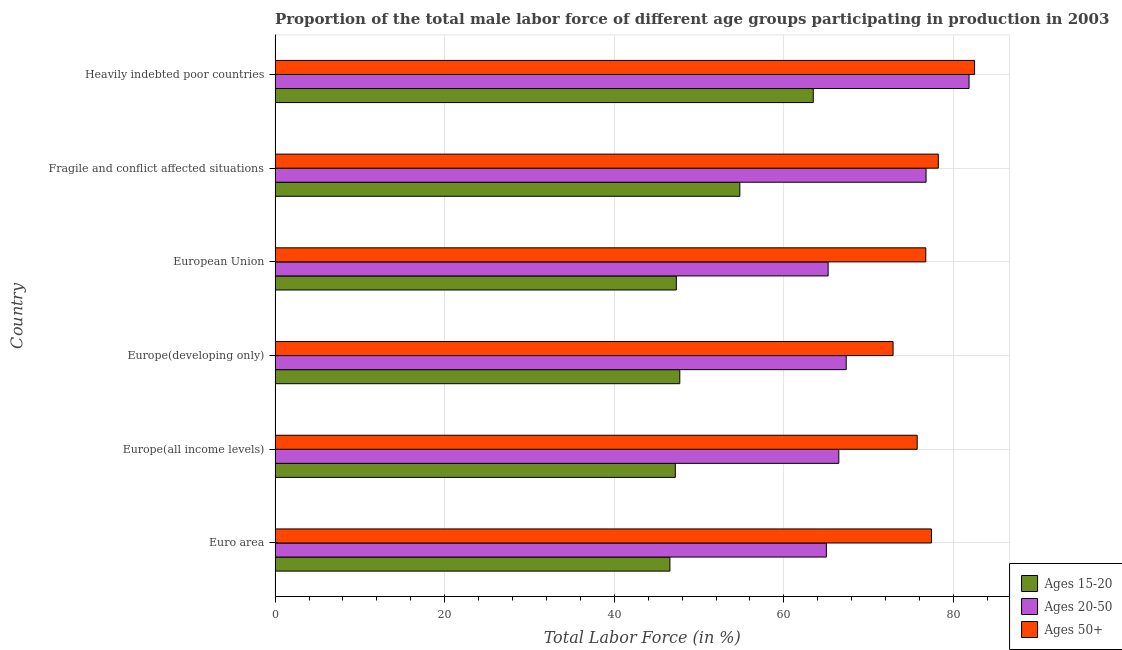How many different coloured bars are there?
Provide a short and direct response. 3. How many bars are there on the 3rd tick from the top?
Your answer should be compact. 3. How many bars are there on the 4th tick from the bottom?
Ensure brevity in your answer.  3. What is the label of the 6th group of bars from the top?
Offer a terse response. Euro area. What is the percentage of male labor force within the age group 20-50 in European Union?
Keep it short and to the point. 65.22. Across all countries, what is the maximum percentage of male labor force above age 50?
Offer a terse response. 82.49. Across all countries, what is the minimum percentage of male labor force above age 50?
Your answer should be very brief. 72.87. In which country was the percentage of male labor force within the age group 15-20 maximum?
Your answer should be very brief. Heavily indebted poor countries. What is the total percentage of male labor force within the age group 20-50 in the graph?
Provide a succinct answer. 422.65. What is the difference between the percentage of male labor force within the age group 20-50 in Euro area and that in Europe(all income levels)?
Keep it short and to the point. -1.47. What is the difference between the percentage of male labor force within the age group 20-50 in Europe(all income levels) and the percentage of male labor force within the age group 15-20 in European Union?
Provide a short and direct response. 19.16. What is the average percentage of male labor force above age 50 per country?
Ensure brevity in your answer.  77.24. What is the difference between the percentage of male labor force above age 50 and percentage of male labor force within the age group 15-20 in Europe(developing only)?
Keep it short and to the point. 25.15. What is the ratio of the percentage of male labor force within the age group 15-20 in Euro area to that in Heavily indebted poor countries?
Your answer should be compact. 0.73. Is the percentage of male labor force within the age group 15-20 in Fragile and conflict affected situations less than that in Heavily indebted poor countries?
Provide a succinct answer. Yes. What is the difference between the highest and the second highest percentage of male labor force within the age group 20-50?
Provide a succinct answer. 5.07. What is the difference between the highest and the lowest percentage of male labor force within the age group 15-20?
Your answer should be very brief. 16.91. What does the 3rd bar from the top in Europe(all income levels) represents?
Ensure brevity in your answer.  Ages 15-20. What does the 2nd bar from the bottom in Euro area represents?
Offer a very short reply. Ages 20-50. Is it the case that in every country, the sum of the percentage of male labor force within the age group 15-20 and percentage of male labor force within the age group 20-50 is greater than the percentage of male labor force above age 50?
Keep it short and to the point. Yes. What is the difference between two consecutive major ticks on the X-axis?
Ensure brevity in your answer.  20. Are the values on the major ticks of X-axis written in scientific E-notation?
Provide a succinct answer. No. Does the graph contain any zero values?
Ensure brevity in your answer.  No. Does the graph contain grids?
Your answer should be very brief. Yes. Where does the legend appear in the graph?
Your response must be concise. Bottom right. What is the title of the graph?
Your response must be concise. Proportion of the total male labor force of different age groups participating in production in 2003. What is the Total Labor Force (in %) in Ages 15-20 in Euro area?
Keep it short and to the point. 46.56. What is the Total Labor Force (in %) of Ages 20-50 in Euro area?
Give a very brief answer. 65.01. What is the Total Labor Force (in %) in Ages 50+ in Euro area?
Ensure brevity in your answer.  77.4. What is the Total Labor Force (in %) in Ages 15-20 in Europe(all income levels)?
Your answer should be compact. 47.2. What is the Total Labor Force (in %) of Ages 20-50 in Europe(all income levels)?
Ensure brevity in your answer.  66.48. What is the Total Labor Force (in %) of Ages 50+ in Europe(all income levels)?
Your response must be concise. 75.72. What is the Total Labor Force (in %) of Ages 15-20 in Europe(developing only)?
Give a very brief answer. 47.72. What is the Total Labor Force (in %) in Ages 20-50 in Europe(developing only)?
Your response must be concise. 67.35. What is the Total Labor Force (in %) in Ages 50+ in Europe(developing only)?
Make the answer very short. 72.87. What is the Total Labor Force (in %) of Ages 15-20 in European Union?
Ensure brevity in your answer.  47.31. What is the Total Labor Force (in %) of Ages 20-50 in European Union?
Give a very brief answer. 65.22. What is the Total Labor Force (in %) of Ages 50+ in European Union?
Provide a short and direct response. 76.73. What is the Total Labor Force (in %) in Ages 15-20 in Fragile and conflict affected situations?
Your answer should be very brief. 54.8. What is the Total Labor Force (in %) in Ages 20-50 in Fragile and conflict affected situations?
Your response must be concise. 76.76. What is the Total Labor Force (in %) of Ages 50+ in Fragile and conflict affected situations?
Make the answer very short. 78.21. What is the Total Labor Force (in %) in Ages 15-20 in Heavily indebted poor countries?
Make the answer very short. 63.46. What is the Total Labor Force (in %) in Ages 20-50 in Heavily indebted poor countries?
Your answer should be very brief. 81.84. What is the Total Labor Force (in %) in Ages 50+ in Heavily indebted poor countries?
Your answer should be compact. 82.49. Across all countries, what is the maximum Total Labor Force (in %) in Ages 15-20?
Provide a succinct answer. 63.46. Across all countries, what is the maximum Total Labor Force (in %) in Ages 20-50?
Make the answer very short. 81.84. Across all countries, what is the maximum Total Labor Force (in %) in Ages 50+?
Keep it short and to the point. 82.49. Across all countries, what is the minimum Total Labor Force (in %) of Ages 15-20?
Make the answer very short. 46.56. Across all countries, what is the minimum Total Labor Force (in %) in Ages 20-50?
Your answer should be very brief. 65.01. Across all countries, what is the minimum Total Labor Force (in %) of Ages 50+?
Give a very brief answer. 72.87. What is the total Total Labor Force (in %) in Ages 15-20 in the graph?
Your answer should be very brief. 307.06. What is the total Total Labor Force (in %) in Ages 20-50 in the graph?
Your response must be concise. 422.65. What is the total Total Labor Force (in %) of Ages 50+ in the graph?
Keep it short and to the point. 463.42. What is the difference between the Total Labor Force (in %) of Ages 15-20 in Euro area and that in Europe(all income levels)?
Give a very brief answer. -0.64. What is the difference between the Total Labor Force (in %) of Ages 20-50 in Euro area and that in Europe(all income levels)?
Your answer should be very brief. -1.46. What is the difference between the Total Labor Force (in %) of Ages 50+ in Euro area and that in Europe(all income levels)?
Provide a succinct answer. 1.68. What is the difference between the Total Labor Force (in %) of Ages 15-20 in Euro area and that in Europe(developing only)?
Keep it short and to the point. -1.17. What is the difference between the Total Labor Force (in %) of Ages 20-50 in Euro area and that in Europe(developing only)?
Your answer should be compact. -2.34. What is the difference between the Total Labor Force (in %) of Ages 50+ in Euro area and that in Europe(developing only)?
Ensure brevity in your answer.  4.53. What is the difference between the Total Labor Force (in %) of Ages 15-20 in Euro area and that in European Union?
Provide a succinct answer. -0.76. What is the difference between the Total Labor Force (in %) in Ages 20-50 in Euro area and that in European Union?
Provide a succinct answer. -0.21. What is the difference between the Total Labor Force (in %) in Ages 50+ in Euro area and that in European Union?
Offer a terse response. 0.67. What is the difference between the Total Labor Force (in %) of Ages 15-20 in Euro area and that in Fragile and conflict affected situations?
Your answer should be very brief. -8.24. What is the difference between the Total Labor Force (in %) of Ages 20-50 in Euro area and that in Fragile and conflict affected situations?
Offer a terse response. -11.75. What is the difference between the Total Labor Force (in %) of Ages 50+ in Euro area and that in Fragile and conflict affected situations?
Your response must be concise. -0.81. What is the difference between the Total Labor Force (in %) of Ages 15-20 in Euro area and that in Heavily indebted poor countries?
Offer a terse response. -16.91. What is the difference between the Total Labor Force (in %) of Ages 20-50 in Euro area and that in Heavily indebted poor countries?
Make the answer very short. -16.82. What is the difference between the Total Labor Force (in %) of Ages 50+ in Euro area and that in Heavily indebted poor countries?
Make the answer very short. -5.09. What is the difference between the Total Labor Force (in %) in Ages 15-20 in Europe(all income levels) and that in Europe(developing only)?
Offer a very short reply. -0.53. What is the difference between the Total Labor Force (in %) of Ages 20-50 in Europe(all income levels) and that in Europe(developing only)?
Keep it short and to the point. -0.87. What is the difference between the Total Labor Force (in %) in Ages 50+ in Europe(all income levels) and that in Europe(developing only)?
Ensure brevity in your answer.  2.85. What is the difference between the Total Labor Force (in %) of Ages 15-20 in Europe(all income levels) and that in European Union?
Provide a succinct answer. -0.12. What is the difference between the Total Labor Force (in %) in Ages 20-50 in Europe(all income levels) and that in European Union?
Make the answer very short. 1.26. What is the difference between the Total Labor Force (in %) in Ages 50+ in Europe(all income levels) and that in European Union?
Your answer should be compact. -1.01. What is the difference between the Total Labor Force (in %) of Ages 15-20 in Europe(all income levels) and that in Fragile and conflict affected situations?
Provide a short and direct response. -7.61. What is the difference between the Total Labor Force (in %) of Ages 20-50 in Europe(all income levels) and that in Fragile and conflict affected situations?
Your answer should be compact. -10.29. What is the difference between the Total Labor Force (in %) in Ages 50+ in Europe(all income levels) and that in Fragile and conflict affected situations?
Provide a succinct answer. -2.49. What is the difference between the Total Labor Force (in %) of Ages 15-20 in Europe(all income levels) and that in Heavily indebted poor countries?
Offer a terse response. -16.27. What is the difference between the Total Labor Force (in %) of Ages 20-50 in Europe(all income levels) and that in Heavily indebted poor countries?
Ensure brevity in your answer.  -15.36. What is the difference between the Total Labor Force (in %) in Ages 50+ in Europe(all income levels) and that in Heavily indebted poor countries?
Give a very brief answer. -6.77. What is the difference between the Total Labor Force (in %) of Ages 15-20 in Europe(developing only) and that in European Union?
Offer a very short reply. 0.41. What is the difference between the Total Labor Force (in %) of Ages 20-50 in Europe(developing only) and that in European Union?
Your response must be concise. 2.13. What is the difference between the Total Labor Force (in %) of Ages 50+ in Europe(developing only) and that in European Union?
Keep it short and to the point. -3.86. What is the difference between the Total Labor Force (in %) of Ages 15-20 in Europe(developing only) and that in Fragile and conflict affected situations?
Your answer should be compact. -7.08. What is the difference between the Total Labor Force (in %) in Ages 20-50 in Europe(developing only) and that in Fragile and conflict affected situations?
Provide a short and direct response. -9.42. What is the difference between the Total Labor Force (in %) in Ages 50+ in Europe(developing only) and that in Fragile and conflict affected situations?
Your answer should be very brief. -5.34. What is the difference between the Total Labor Force (in %) in Ages 15-20 in Europe(developing only) and that in Heavily indebted poor countries?
Offer a terse response. -15.74. What is the difference between the Total Labor Force (in %) in Ages 20-50 in Europe(developing only) and that in Heavily indebted poor countries?
Keep it short and to the point. -14.49. What is the difference between the Total Labor Force (in %) in Ages 50+ in Europe(developing only) and that in Heavily indebted poor countries?
Make the answer very short. -9.61. What is the difference between the Total Labor Force (in %) of Ages 15-20 in European Union and that in Fragile and conflict affected situations?
Your answer should be compact. -7.49. What is the difference between the Total Labor Force (in %) in Ages 20-50 in European Union and that in Fragile and conflict affected situations?
Keep it short and to the point. -11.55. What is the difference between the Total Labor Force (in %) of Ages 50+ in European Union and that in Fragile and conflict affected situations?
Offer a terse response. -1.48. What is the difference between the Total Labor Force (in %) in Ages 15-20 in European Union and that in Heavily indebted poor countries?
Provide a succinct answer. -16.15. What is the difference between the Total Labor Force (in %) of Ages 20-50 in European Union and that in Heavily indebted poor countries?
Your answer should be very brief. -16.62. What is the difference between the Total Labor Force (in %) of Ages 50+ in European Union and that in Heavily indebted poor countries?
Give a very brief answer. -5.75. What is the difference between the Total Labor Force (in %) in Ages 15-20 in Fragile and conflict affected situations and that in Heavily indebted poor countries?
Your answer should be very brief. -8.66. What is the difference between the Total Labor Force (in %) in Ages 20-50 in Fragile and conflict affected situations and that in Heavily indebted poor countries?
Provide a short and direct response. -5.07. What is the difference between the Total Labor Force (in %) of Ages 50+ in Fragile and conflict affected situations and that in Heavily indebted poor countries?
Provide a short and direct response. -4.28. What is the difference between the Total Labor Force (in %) in Ages 15-20 in Euro area and the Total Labor Force (in %) in Ages 20-50 in Europe(all income levels)?
Your response must be concise. -19.92. What is the difference between the Total Labor Force (in %) in Ages 15-20 in Euro area and the Total Labor Force (in %) in Ages 50+ in Europe(all income levels)?
Your response must be concise. -29.16. What is the difference between the Total Labor Force (in %) of Ages 20-50 in Euro area and the Total Labor Force (in %) of Ages 50+ in Europe(all income levels)?
Your answer should be compact. -10.71. What is the difference between the Total Labor Force (in %) of Ages 15-20 in Euro area and the Total Labor Force (in %) of Ages 20-50 in Europe(developing only)?
Your response must be concise. -20.79. What is the difference between the Total Labor Force (in %) in Ages 15-20 in Euro area and the Total Labor Force (in %) in Ages 50+ in Europe(developing only)?
Offer a very short reply. -26.31. What is the difference between the Total Labor Force (in %) of Ages 20-50 in Euro area and the Total Labor Force (in %) of Ages 50+ in Europe(developing only)?
Offer a terse response. -7.86. What is the difference between the Total Labor Force (in %) in Ages 15-20 in Euro area and the Total Labor Force (in %) in Ages 20-50 in European Union?
Your answer should be compact. -18.66. What is the difference between the Total Labor Force (in %) of Ages 15-20 in Euro area and the Total Labor Force (in %) of Ages 50+ in European Union?
Keep it short and to the point. -30.17. What is the difference between the Total Labor Force (in %) in Ages 20-50 in Euro area and the Total Labor Force (in %) in Ages 50+ in European Union?
Your answer should be compact. -11.72. What is the difference between the Total Labor Force (in %) of Ages 15-20 in Euro area and the Total Labor Force (in %) of Ages 20-50 in Fragile and conflict affected situations?
Provide a succinct answer. -30.21. What is the difference between the Total Labor Force (in %) in Ages 15-20 in Euro area and the Total Labor Force (in %) in Ages 50+ in Fragile and conflict affected situations?
Offer a very short reply. -31.65. What is the difference between the Total Labor Force (in %) of Ages 20-50 in Euro area and the Total Labor Force (in %) of Ages 50+ in Fragile and conflict affected situations?
Your response must be concise. -13.2. What is the difference between the Total Labor Force (in %) of Ages 15-20 in Euro area and the Total Labor Force (in %) of Ages 20-50 in Heavily indebted poor countries?
Your answer should be compact. -35.28. What is the difference between the Total Labor Force (in %) in Ages 15-20 in Euro area and the Total Labor Force (in %) in Ages 50+ in Heavily indebted poor countries?
Provide a succinct answer. -35.93. What is the difference between the Total Labor Force (in %) of Ages 20-50 in Euro area and the Total Labor Force (in %) of Ages 50+ in Heavily indebted poor countries?
Give a very brief answer. -17.47. What is the difference between the Total Labor Force (in %) of Ages 15-20 in Europe(all income levels) and the Total Labor Force (in %) of Ages 20-50 in Europe(developing only)?
Your answer should be very brief. -20.15. What is the difference between the Total Labor Force (in %) of Ages 15-20 in Europe(all income levels) and the Total Labor Force (in %) of Ages 50+ in Europe(developing only)?
Provide a succinct answer. -25.67. What is the difference between the Total Labor Force (in %) of Ages 20-50 in Europe(all income levels) and the Total Labor Force (in %) of Ages 50+ in Europe(developing only)?
Your answer should be compact. -6.4. What is the difference between the Total Labor Force (in %) of Ages 15-20 in Europe(all income levels) and the Total Labor Force (in %) of Ages 20-50 in European Union?
Make the answer very short. -18.02. What is the difference between the Total Labor Force (in %) of Ages 15-20 in Europe(all income levels) and the Total Labor Force (in %) of Ages 50+ in European Union?
Keep it short and to the point. -29.53. What is the difference between the Total Labor Force (in %) of Ages 20-50 in Europe(all income levels) and the Total Labor Force (in %) of Ages 50+ in European Union?
Ensure brevity in your answer.  -10.26. What is the difference between the Total Labor Force (in %) in Ages 15-20 in Europe(all income levels) and the Total Labor Force (in %) in Ages 20-50 in Fragile and conflict affected situations?
Provide a short and direct response. -29.57. What is the difference between the Total Labor Force (in %) in Ages 15-20 in Europe(all income levels) and the Total Labor Force (in %) in Ages 50+ in Fragile and conflict affected situations?
Offer a terse response. -31.01. What is the difference between the Total Labor Force (in %) in Ages 20-50 in Europe(all income levels) and the Total Labor Force (in %) in Ages 50+ in Fragile and conflict affected situations?
Your answer should be very brief. -11.73. What is the difference between the Total Labor Force (in %) of Ages 15-20 in Europe(all income levels) and the Total Labor Force (in %) of Ages 20-50 in Heavily indebted poor countries?
Keep it short and to the point. -34.64. What is the difference between the Total Labor Force (in %) in Ages 15-20 in Europe(all income levels) and the Total Labor Force (in %) in Ages 50+ in Heavily indebted poor countries?
Your response must be concise. -35.29. What is the difference between the Total Labor Force (in %) in Ages 20-50 in Europe(all income levels) and the Total Labor Force (in %) in Ages 50+ in Heavily indebted poor countries?
Offer a very short reply. -16.01. What is the difference between the Total Labor Force (in %) of Ages 15-20 in Europe(developing only) and the Total Labor Force (in %) of Ages 20-50 in European Union?
Make the answer very short. -17.49. What is the difference between the Total Labor Force (in %) in Ages 15-20 in Europe(developing only) and the Total Labor Force (in %) in Ages 50+ in European Union?
Your response must be concise. -29.01. What is the difference between the Total Labor Force (in %) of Ages 20-50 in Europe(developing only) and the Total Labor Force (in %) of Ages 50+ in European Union?
Make the answer very short. -9.39. What is the difference between the Total Labor Force (in %) of Ages 15-20 in Europe(developing only) and the Total Labor Force (in %) of Ages 20-50 in Fragile and conflict affected situations?
Your answer should be very brief. -29.04. What is the difference between the Total Labor Force (in %) of Ages 15-20 in Europe(developing only) and the Total Labor Force (in %) of Ages 50+ in Fragile and conflict affected situations?
Provide a succinct answer. -30.49. What is the difference between the Total Labor Force (in %) of Ages 20-50 in Europe(developing only) and the Total Labor Force (in %) of Ages 50+ in Fragile and conflict affected situations?
Make the answer very short. -10.86. What is the difference between the Total Labor Force (in %) of Ages 15-20 in Europe(developing only) and the Total Labor Force (in %) of Ages 20-50 in Heavily indebted poor countries?
Ensure brevity in your answer.  -34.11. What is the difference between the Total Labor Force (in %) of Ages 15-20 in Europe(developing only) and the Total Labor Force (in %) of Ages 50+ in Heavily indebted poor countries?
Your answer should be compact. -34.76. What is the difference between the Total Labor Force (in %) in Ages 20-50 in Europe(developing only) and the Total Labor Force (in %) in Ages 50+ in Heavily indebted poor countries?
Your answer should be compact. -15.14. What is the difference between the Total Labor Force (in %) in Ages 15-20 in European Union and the Total Labor Force (in %) in Ages 20-50 in Fragile and conflict affected situations?
Give a very brief answer. -29.45. What is the difference between the Total Labor Force (in %) in Ages 15-20 in European Union and the Total Labor Force (in %) in Ages 50+ in Fragile and conflict affected situations?
Offer a very short reply. -30.9. What is the difference between the Total Labor Force (in %) of Ages 20-50 in European Union and the Total Labor Force (in %) of Ages 50+ in Fragile and conflict affected situations?
Keep it short and to the point. -12.99. What is the difference between the Total Labor Force (in %) in Ages 15-20 in European Union and the Total Labor Force (in %) in Ages 20-50 in Heavily indebted poor countries?
Offer a very short reply. -34.52. What is the difference between the Total Labor Force (in %) in Ages 15-20 in European Union and the Total Labor Force (in %) in Ages 50+ in Heavily indebted poor countries?
Offer a terse response. -35.17. What is the difference between the Total Labor Force (in %) in Ages 20-50 in European Union and the Total Labor Force (in %) in Ages 50+ in Heavily indebted poor countries?
Your answer should be compact. -17.27. What is the difference between the Total Labor Force (in %) in Ages 15-20 in Fragile and conflict affected situations and the Total Labor Force (in %) in Ages 20-50 in Heavily indebted poor countries?
Provide a short and direct response. -27.03. What is the difference between the Total Labor Force (in %) of Ages 15-20 in Fragile and conflict affected situations and the Total Labor Force (in %) of Ages 50+ in Heavily indebted poor countries?
Provide a succinct answer. -27.68. What is the difference between the Total Labor Force (in %) of Ages 20-50 in Fragile and conflict affected situations and the Total Labor Force (in %) of Ages 50+ in Heavily indebted poor countries?
Offer a very short reply. -5.72. What is the average Total Labor Force (in %) in Ages 15-20 per country?
Keep it short and to the point. 51.18. What is the average Total Labor Force (in %) of Ages 20-50 per country?
Keep it short and to the point. 70.44. What is the average Total Labor Force (in %) of Ages 50+ per country?
Your answer should be compact. 77.24. What is the difference between the Total Labor Force (in %) in Ages 15-20 and Total Labor Force (in %) in Ages 20-50 in Euro area?
Your answer should be compact. -18.45. What is the difference between the Total Labor Force (in %) in Ages 15-20 and Total Labor Force (in %) in Ages 50+ in Euro area?
Provide a short and direct response. -30.84. What is the difference between the Total Labor Force (in %) in Ages 20-50 and Total Labor Force (in %) in Ages 50+ in Euro area?
Your answer should be very brief. -12.39. What is the difference between the Total Labor Force (in %) in Ages 15-20 and Total Labor Force (in %) in Ages 20-50 in Europe(all income levels)?
Your response must be concise. -19.28. What is the difference between the Total Labor Force (in %) in Ages 15-20 and Total Labor Force (in %) in Ages 50+ in Europe(all income levels)?
Your answer should be very brief. -28.52. What is the difference between the Total Labor Force (in %) in Ages 20-50 and Total Labor Force (in %) in Ages 50+ in Europe(all income levels)?
Keep it short and to the point. -9.24. What is the difference between the Total Labor Force (in %) in Ages 15-20 and Total Labor Force (in %) in Ages 20-50 in Europe(developing only)?
Your answer should be compact. -19.62. What is the difference between the Total Labor Force (in %) in Ages 15-20 and Total Labor Force (in %) in Ages 50+ in Europe(developing only)?
Offer a terse response. -25.15. What is the difference between the Total Labor Force (in %) in Ages 20-50 and Total Labor Force (in %) in Ages 50+ in Europe(developing only)?
Your response must be concise. -5.53. What is the difference between the Total Labor Force (in %) in Ages 15-20 and Total Labor Force (in %) in Ages 20-50 in European Union?
Give a very brief answer. -17.9. What is the difference between the Total Labor Force (in %) in Ages 15-20 and Total Labor Force (in %) in Ages 50+ in European Union?
Provide a succinct answer. -29.42. What is the difference between the Total Labor Force (in %) of Ages 20-50 and Total Labor Force (in %) of Ages 50+ in European Union?
Provide a short and direct response. -11.52. What is the difference between the Total Labor Force (in %) of Ages 15-20 and Total Labor Force (in %) of Ages 20-50 in Fragile and conflict affected situations?
Provide a succinct answer. -21.96. What is the difference between the Total Labor Force (in %) in Ages 15-20 and Total Labor Force (in %) in Ages 50+ in Fragile and conflict affected situations?
Provide a short and direct response. -23.41. What is the difference between the Total Labor Force (in %) of Ages 20-50 and Total Labor Force (in %) of Ages 50+ in Fragile and conflict affected situations?
Provide a short and direct response. -1.45. What is the difference between the Total Labor Force (in %) in Ages 15-20 and Total Labor Force (in %) in Ages 20-50 in Heavily indebted poor countries?
Provide a succinct answer. -18.37. What is the difference between the Total Labor Force (in %) of Ages 15-20 and Total Labor Force (in %) of Ages 50+ in Heavily indebted poor countries?
Ensure brevity in your answer.  -19.02. What is the difference between the Total Labor Force (in %) of Ages 20-50 and Total Labor Force (in %) of Ages 50+ in Heavily indebted poor countries?
Make the answer very short. -0.65. What is the ratio of the Total Labor Force (in %) in Ages 15-20 in Euro area to that in Europe(all income levels)?
Make the answer very short. 0.99. What is the ratio of the Total Labor Force (in %) in Ages 20-50 in Euro area to that in Europe(all income levels)?
Your answer should be very brief. 0.98. What is the ratio of the Total Labor Force (in %) of Ages 50+ in Euro area to that in Europe(all income levels)?
Offer a terse response. 1.02. What is the ratio of the Total Labor Force (in %) of Ages 15-20 in Euro area to that in Europe(developing only)?
Offer a terse response. 0.98. What is the ratio of the Total Labor Force (in %) of Ages 20-50 in Euro area to that in Europe(developing only)?
Give a very brief answer. 0.97. What is the ratio of the Total Labor Force (in %) of Ages 50+ in Euro area to that in Europe(developing only)?
Provide a short and direct response. 1.06. What is the ratio of the Total Labor Force (in %) in Ages 20-50 in Euro area to that in European Union?
Your response must be concise. 1. What is the ratio of the Total Labor Force (in %) in Ages 50+ in Euro area to that in European Union?
Your response must be concise. 1.01. What is the ratio of the Total Labor Force (in %) in Ages 15-20 in Euro area to that in Fragile and conflict affected situations?
Make the answer very short. 0.85. What is the ratio of the Total Labor Force (in %) in Ages 20-50 in Euro area to that in Fragile and conflict affected situations?
Give a very brief answer. 0.85. What is the ratio of the Total Labor Force (in %) in Ages 15-20 in Euro area to that in Heavily indebted poor countries?
Offer a very short reply. 0.73. What is the ratio of the Total Labor Force (in %) in Ages 20-50 in Euro area to that in Heavily indebted poor countries?
Make the answer very short. 0.79. What is the ratio of the Total Labor Force (in %) of Ages 50+ in Euro area to that in Heavily indebted poor countries?
Offer a terse response. 0.94. What is the ratio of the Total Labor Force (in %) of Ages 15-20 in Europe(all income levels) to that in Europe(developing only)?
Your answer should be compact. 0.99. What is the ratio of the Total Labor Force (in %) in Ages 20-50 in Europe(all income levels) to that in Europe(developing only)?
Your response must be concise. 0.99. What is the ratio of the Total Labor Force (in %) of Ages 50+ in Europe(all income levels) to that in Europe(developing only)?
Offer a terse response. 1.04. What is the ratio of the Total Labor Force (in %) of Ages 15-20 in Europe(all income levels) to that in European Union?
Keep it short and to the point. 1. What is the ratio of the Total Labor Force (in %) in Ages 20-50 in Europe(all income levels) to that in European Union?
Your answer should be very brief. 1.02. What is the ratio of the Total Labor Force (in %) of Ages 15-20 in Europe(all income levels) to that in Fragile and conflict affected situations?
Offer a very short reply. 0.86. What is the ratio of the Total Labor Force (in %) of Ages 20-50 in Europe(all income levels) to that in Fragile and conflict affected situations?
Your answer should be very brief. 0.87. What is the ratio of the Total Labor Force (in %) in Ages 50+ in Europe(all income levels) to that in Fragile and conflict affected situations?
Offer a terse response. 0.97. What is the ratio of the Total Labor Force (in %) of Ages 15-20 in Europe(all income levels) to that in Heavily indebted poor countries?
Your answer should be compact. 0.74. What is the ratio of the Total Labor Force (in %) of Ages 20-50 in Europe(all income levels) to that in Heavily indebted poor countries?
Your response must be concise. 0.81. What is the ratio of the Total Labor Force (in %) of Ages 50+ in Europe(all income levels) to that in Heavily indebted poor countries?
Keep it short and to the point. 0.92. What is the ratio of the Total Labor Force (in %) in Ages 15-20 in Europe(developing only) to that in European Union?
Offer a very short reply. 1.01. What is the ratio of the Total Labor Force (in %) in Ages 20-50 in Europe(developing only) to that in European Union?
Provide a succinct answer. 1.03. What is the ratio of the Total Labor Force (in %) of Ages 50+ in Europe(developing only) to that in European Union?
Keep it short and to the point. 0.95. What is the ratio of the Total Labor Force (in %) of Ages 15-20 in Europe(developing only) to that in Fragile and conflict affected situations?
Make the answer very short. 0.87. What is the ratio of the Total Labor Force (in %) in Ages 20-50 in Europe(developing only) to that in Fragile and conflict affected situations?
Ensure brevity in your answer.  0.88. What is the ratio of the Total Labor Force (in %) of Ages 50+ in Europe(developing only) to that in Fragile and conflict affected situations?
Ensure brevity in your answer.  0.93. What is the ratio of the Total Labor Force (in %) of Ages 15-20 in Europe(developing only) to that in Heavily indebted poor countries?
Your answer should be very brief. 0.75. What is the ratio of the Total Labor Force (in %) in Ages 20-50 in Europe(developing only) to that in Heavily indebted poor countries?
Provide a short and direct response. 0.82. What is the ratio of the Total Labor Force (in %) of Ages 50+ in Europe(developing only) to that in Heavily indebted poor countries?
Your answer should be very brief. 0.88. What is the ratio of the Total Labor Force (in %) in Ages 15-20 in European Union to that in Fragile and conflict affected situations?
Offer a very short reply. 0.86. What is the ratio of the Total Labor Force (in %) in Ages 20-50 in European Union to that in Fragile and conflict affected situations?
Provide a short and direct response. 0.85. What is the ratio of the Total Labor Force (in %) of Ages 50+ in European Union to that in Fragile and conflict affected situations?
Offer a very short reply. 0.98. What is the ratio of the Total Labor Force (in %) in Ages 15-20 in European Union to that in Heavily indebted poor countries?
Offer a very short reply. 0.75. What is the ratio of the Total Labor Force (in %) in Ages 20-50 in European Union to that in Heavily indebted poor countries?
Give a very brief answer. 0.8. What is the ratio of the Total Labor Force (in %) of Ages 50+ in European Union to that in Heavily indebted poor countries?
Keep it short and to the point. 0.93. What is the ratio of the Total Labor Force (in %) in Ages 15-20 in Fragile and conflict affected situations to that in Heavily indebted poor countries?
Keep it short and to the point. 0.86. What is the ratio of the Total Labor Force (in %) in Ages 20-50 in Fragile and conflict affected situations to that in Heavily indebted poor countries?
Your response must be concise. 0.94. What is the ratio of the Total Labor Force (in %) of Ages 50+ in Fragile and conflict affected situations to that in Heavily indebted poor countries?
Ensure brevity in your answer.  0.95. What is the difference between the highest and the second highest Total Labor Force (in %) in Ages 15-20?
Offer a terse response. 8.66. What is the difference between the highest and the second highest Total Labor Force (in %) in Ages 20-50?
Your answer should be compact. 5.07. What is the difference between the highest and the second highest Total Labor Force (in %) of Ages 50+?
Your response must be concise. 4.28. What is the difference between the highest and the lowest Total Labor Force (in %) of Ages 15-20?
Your response must be concise. 16.91. What is the difference between the highest and the lowest Total Labor Force (in %) in Ages 20-50?
Keep it short and to the point. 16.82. What is the difference between the highest and the lowest Total Labor Force (in %) of Ages 50+?
Provide a short and direct response. 9.61. 